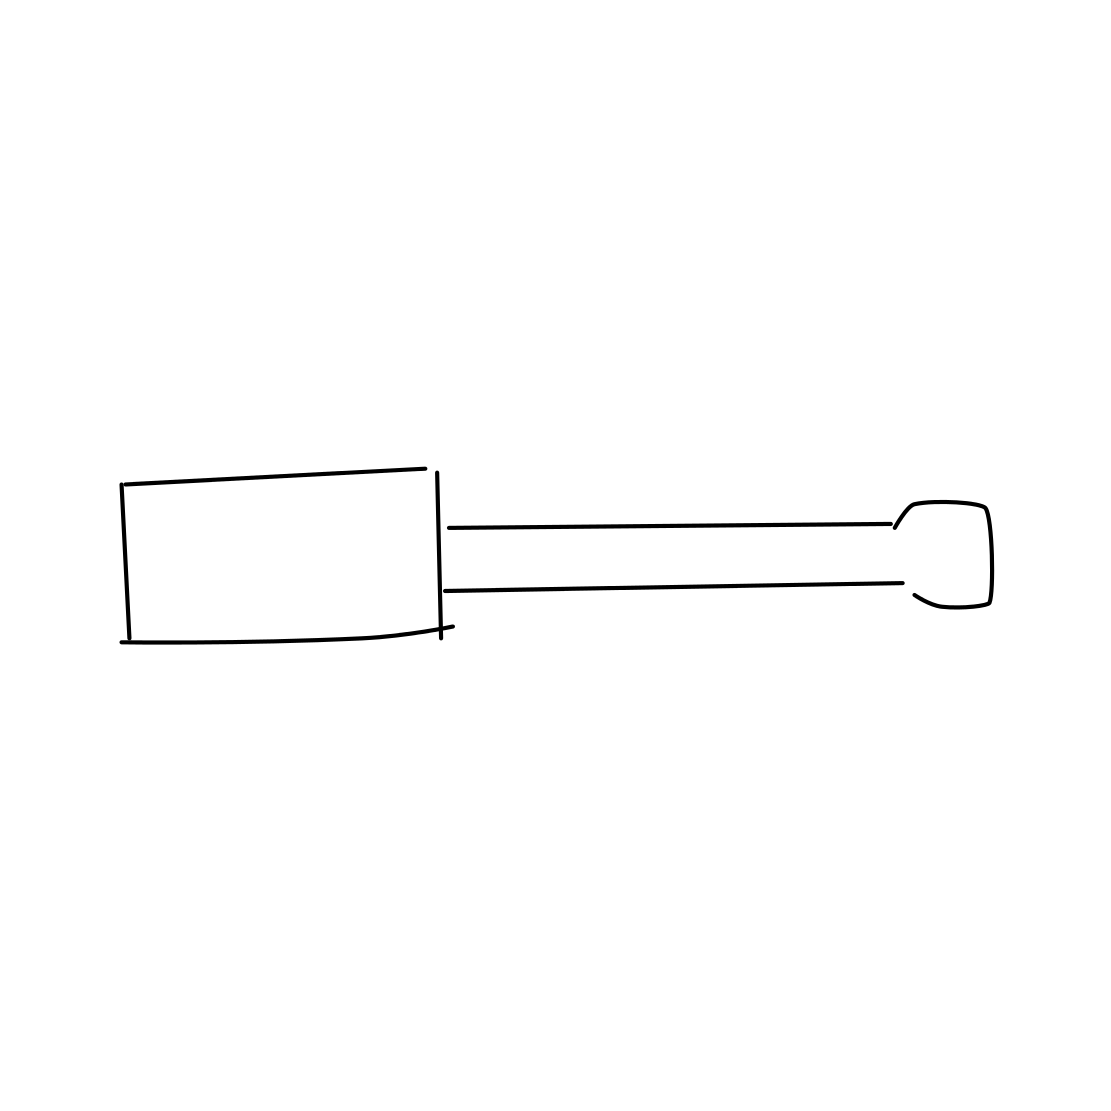What specific type of screwdriver is shown in the image? The screwdriver in the image is a flathead screwdriver, characterized by its flat and straight tip designed for screws with a single horizontal indentation. 